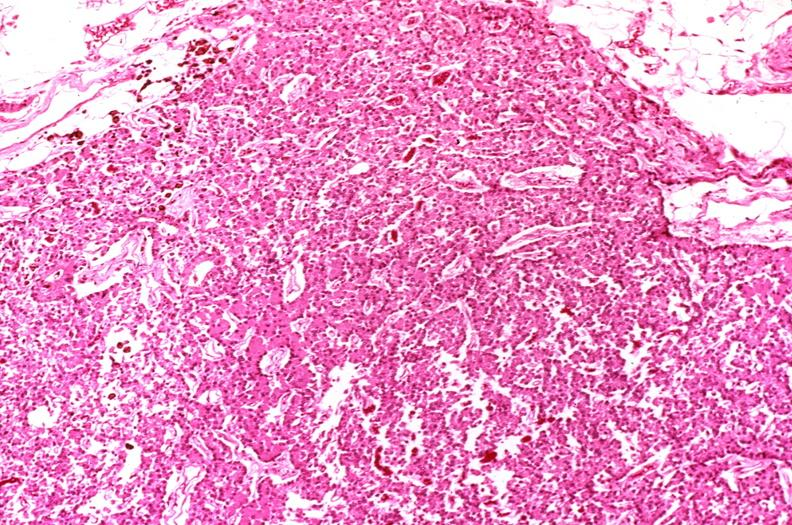where is this part in the figure?
Answer the question using a single word or phrase. Endocrine system 